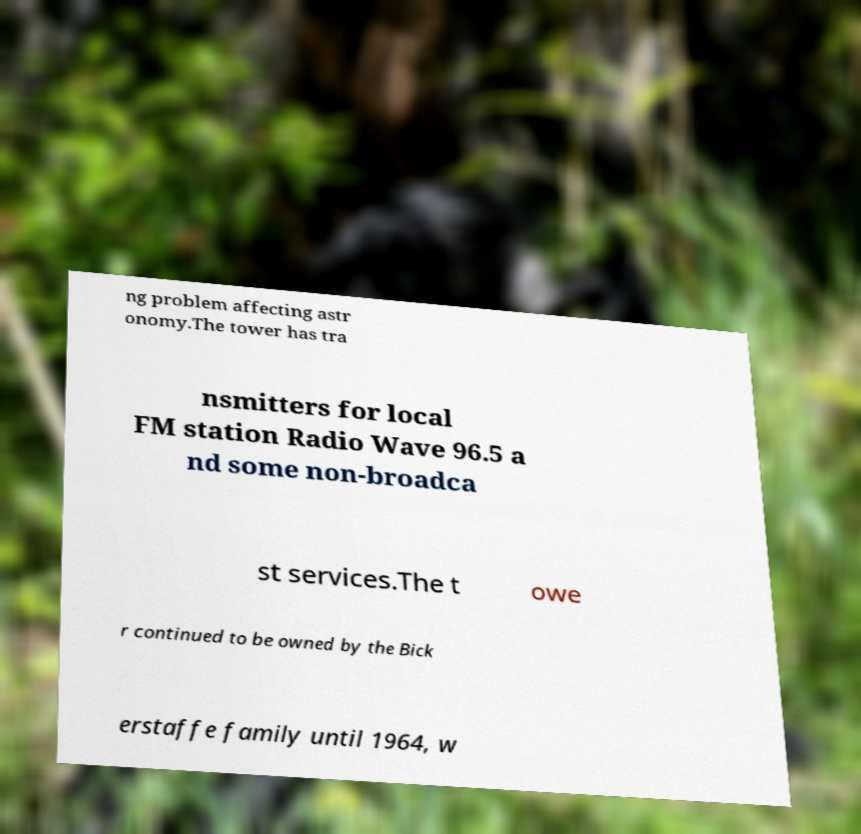Can you accurately transcribe the text from the provided image for me? ng problem affecting astr onomy.The tower has tra nsmitters for local FM station Radio Wave 96.5 a nd some non-broadca st services.The t owe r continued to be owned by the Bick erstaffe family until 1964, w 